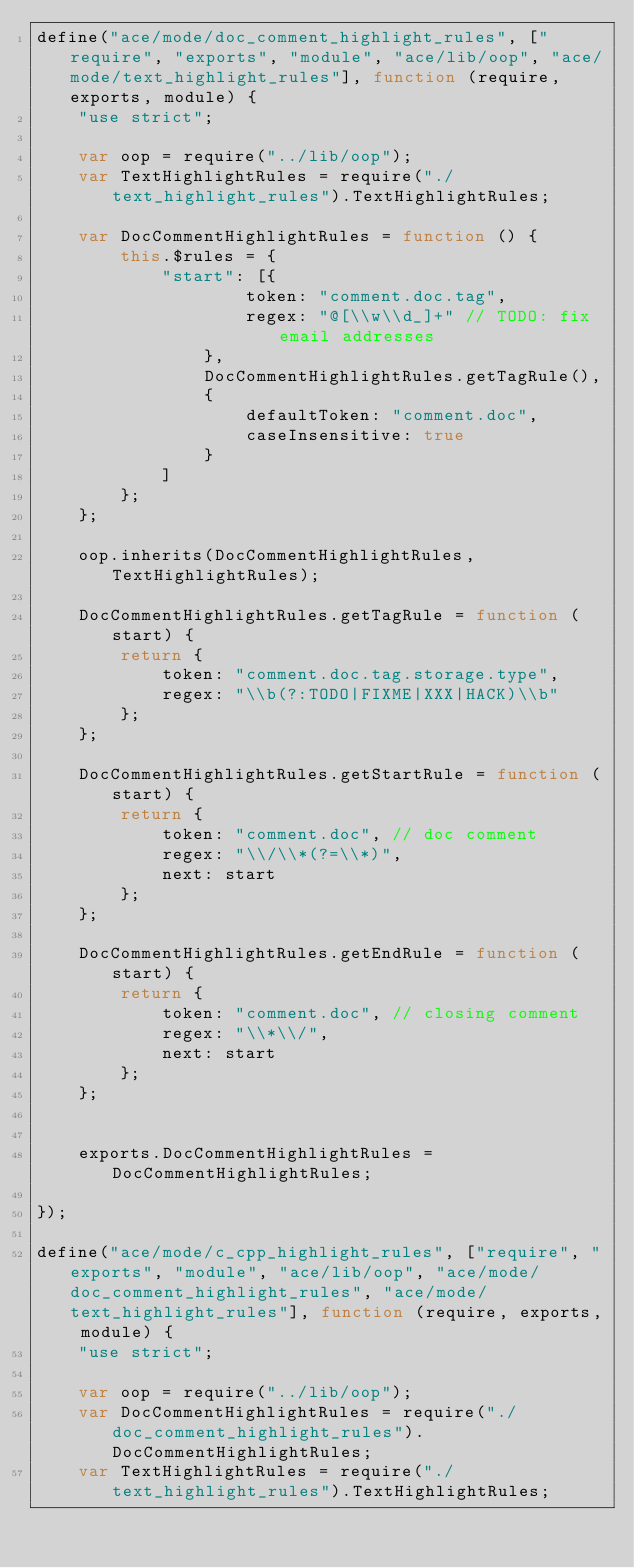<code> <loc_0><loc_0><loc_500><loc_500><_JavaScript_>define("ace/mode/doc_comment_highlight_rules", ["require", "exports", "module", "ace/lib/oop", "ace/mode/text_highlight_rules"], function (require, exports, module) {
    "use strict";

    var oop = require("../lib/oop");
    var TextHighlightRules = require("./text_highlight_rules").TextHighlightRules;

    var DocCommentHighlightRules = function () {
        this.$rules = {
            "start": [{
                    token: "comment.doc.tag",
                    regex: "@[\\w\\d_]+" // TODO: fix email addresses
                },
                DocCommentHighlightRules.getTagRule(),
                {
                    defaultToken: "comment.doc",
                    caseInsensitive: true
                }
            ]
        };
    };

    oop.inherits(DocCommentHighlightRules, TextHighlightRules);

    DocCommentHighlightRules.getTagRule = function (start) {
        return {
            token: "comment.doc.tag.storage.type",
            regex: "\\b(?:TODO|FIXME|XXX|HACK)\\b"
        };
    };

    DocCommentHighlightRules.getStartRule = function (start) {
        return {
            token: "comment.doc", // doc comment
            regex: "\\/\\*(?=\\*)",
            next: start
        };
    };

    DocCommentHighlightRules.getEndRule = function (start) {
        return {
            token: "comment.doc", // closing comment
            regex: "\\*\\/",
            next: start
        };
    };


    exports.DocCommentHighlightRules = DocCommentHighlightRules;

});

define("ace/mode/c_cpp_highlight_rules", ["require", "exports", "module", "ace/lib/oop", "ace/mode/doc_comment_highlight_rules", "ace/mode/text_highlight_rules"], function (require, exports, module) {
    "use strict";

    var oop = require("../lib/oop");
    var DocCommentHighlightRules = require("./doc_comment_highlight_rules").DocCommentHighlightRules;
    var TextHighlightRules = require("./text_highlight_rules").TextHighlightRules;</code> 